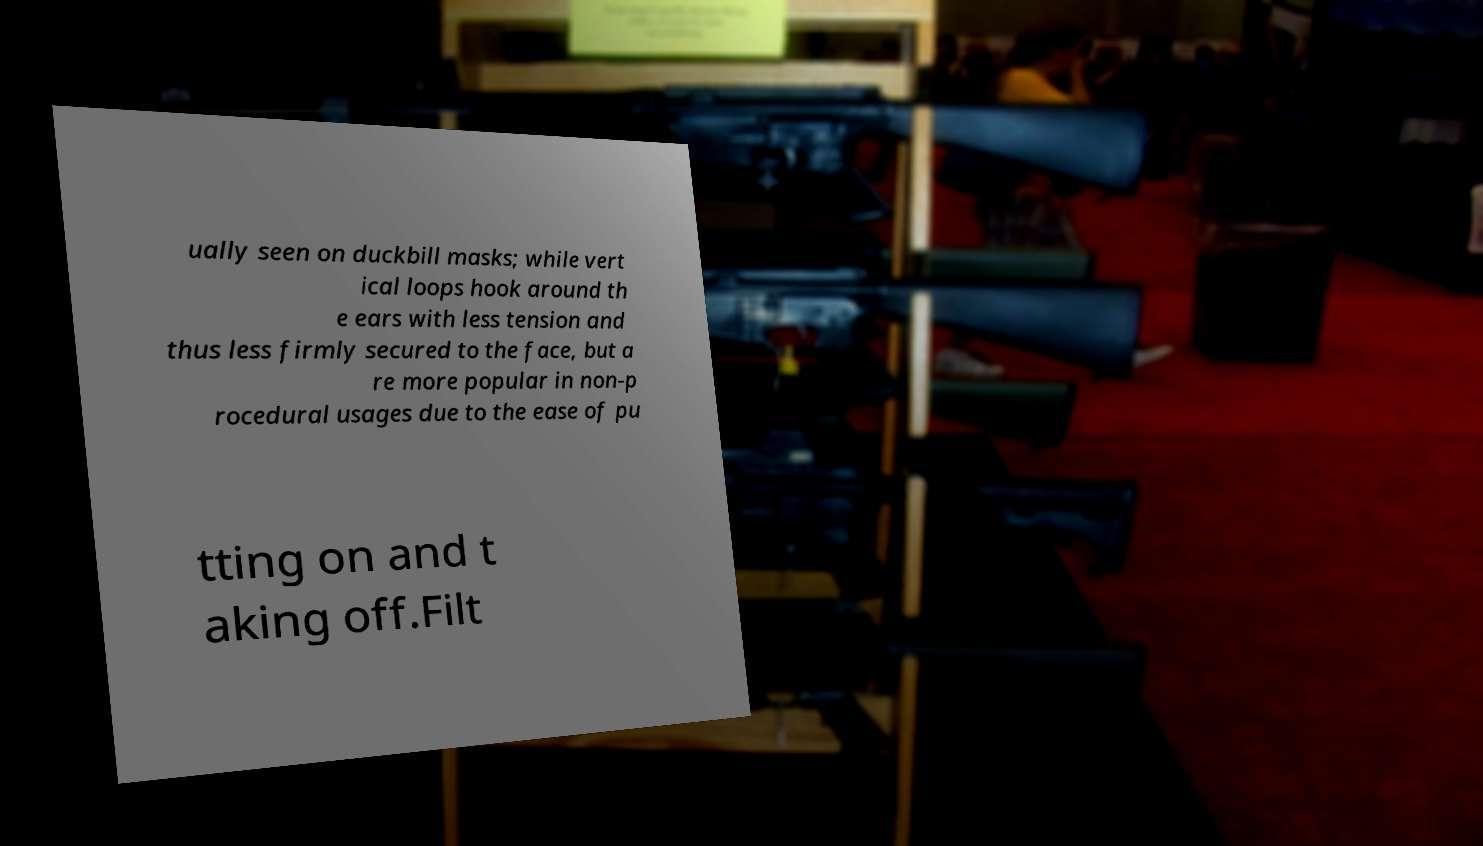Please read and relay the text visible in this image. What does it say? ually seen on duckbill masks; while vert ical loops hook around th e ears with less tension and thus less firmly secured to the face, but a re more popular in non-p rocedural usages due to the ease of pu tting on and t aking off.Filt 